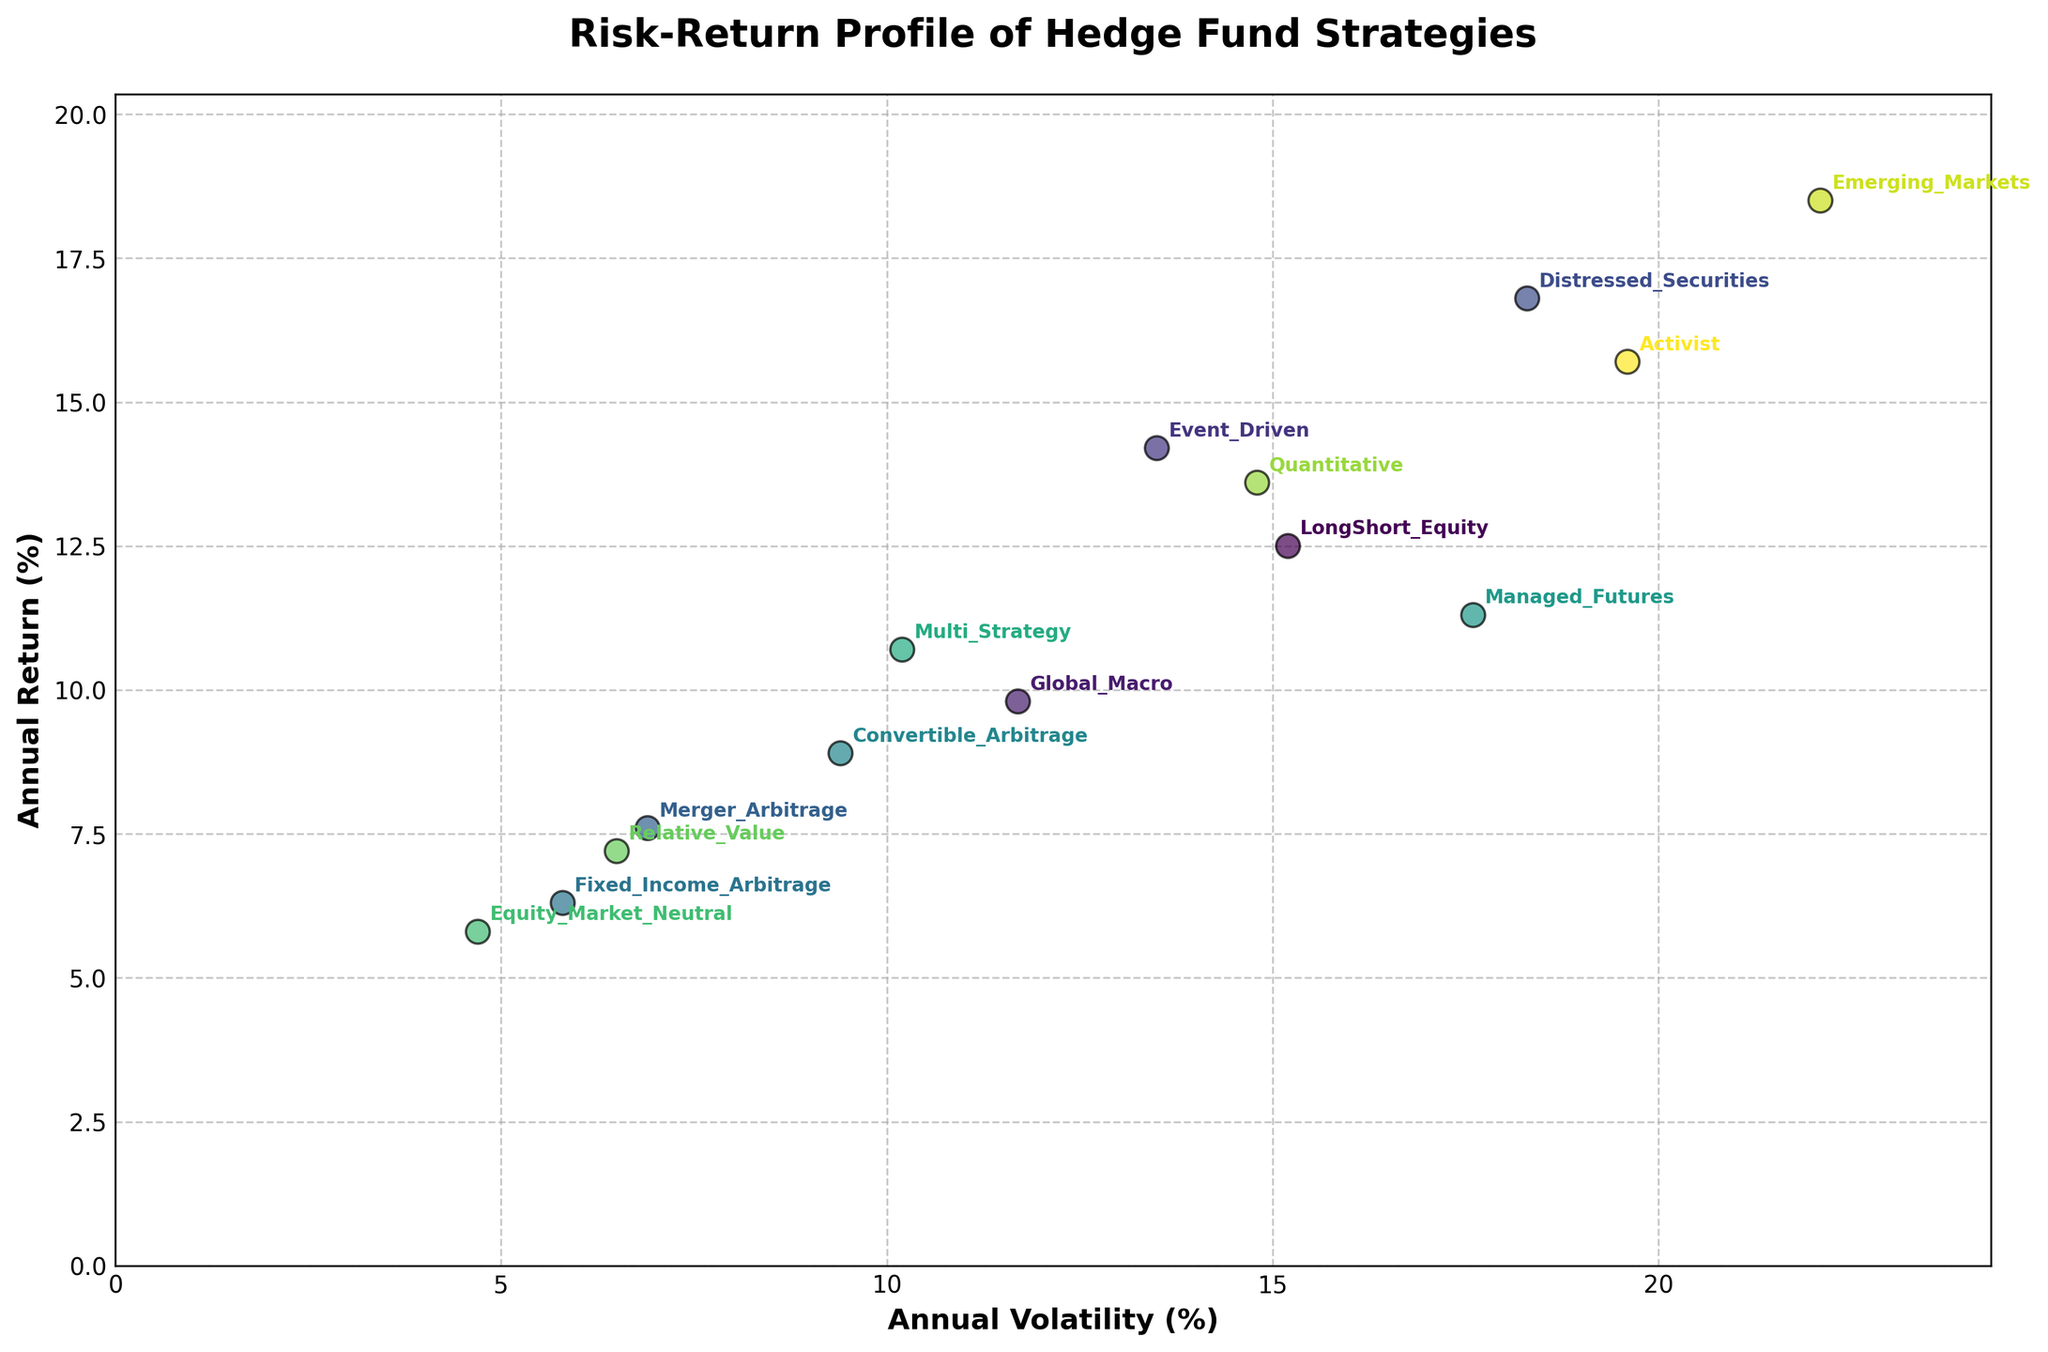What is the title of the figure? The title is usually positioned at the top of the figure; in this specific plot, the title reads "Risk-Return Profile of Hedge Fund Strategies."
Answer: Risk-Return Profile of Hedge Fund Strategies How many hedge fund strategies are represented in the figure? By counting the individual data points in the scatter plot, each of which represents a different strategy, you can determine there are 14 points.
Answer: 14 Which strategy has the highest annual return? Looking at the y-axis, which indicates the annual return, and the labels for the data points, "Emerging Markets" is the strategy with the highest return, positioned at the topmost point.
Answer: Emerging Markets What is the annual volatility and return of the "Fixed Income Arbitrage" strategy? By locating the "Fixed Income Arbitrage" data point and observing its position relative to the x (volatility) and y (return) axes, you can determine the values.
Answer: Volatility = 5.8, Return = 6.3 Which strategy has the lowest annual volatility? Check the data points along the x-axis, indicating volatility, and identify that "Equity Market Neutral" is the farthest left.
Answer: Equity Market Neutral How many strategies have an annual return greater than 15%? By examining the y-axis for points above the 15% mark, you can see that four strategies—Distressed Securities, Emerging Markets, Activist, Event Driven—meet this criterion.
Answer: 4 Compare the annual returns of "Global Macro" and "LongShort Equity" strategies. Which one is higher? Locate both strategies on the y-axis and compare their positions; "LongShort Equity" is higher on the y-axis than "Global Macro."
Answer: LongShort Equity Which strategy has the closest volatility to "Multi Strategy" but a higher annual return? Observe the x-axis for volatilities near "Multi Strategy" (10.2%) and identify that "Event Driven" (13.5%) has a higher return with similar volatility.
Answer: Event Driven What is the average annual return of "Managed Futures" and "Activist" strategies? Sum the annual returns of "Managed Futures" (11.3) and "Activist" (15.7) and then divide by two to find the average: (11.3 + 15.7) / 2.
Answer: 13.5 Which strategy has the highest risk-return ratio and what does it represent? The risk-return ratio is calculated by dividing the annual return by the annual volatility. By calculating ratios for all strategies, "Merger Arbitrage" (7.6/6.9 ≈ 1.10) has the highest ratio, representing the best return per unit of risk.
Answer: Merger Arbitrage, ≈ 1.10 